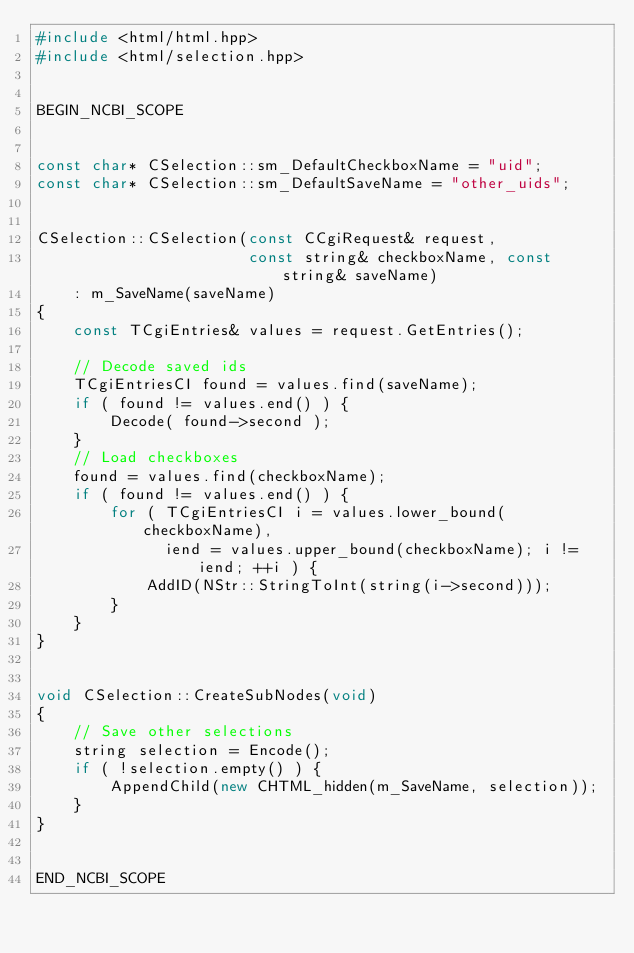<code> <loc_0><loc_0><loc_500><loc_500><_C++_>#include <html/html.hpp>
#include <html/selection.hpp>


BEGIN_NCBI_SCOPE


const char* CSelection::sm_DefaultCheckboxName = "uid";
const char* CSelection::sm_DefaultSaveName = "other_uids";


CSelection::CSelection(const CCgiRequest& request, 
                       const string& checkboxName, const string& saveName)
    : m_SaveName(saveName)
{
    const TCgiEntries& values = request.GetEntries();

    // Decode saved ids
    TCgiEntriesCI found = values.find(saveName);
    if ( found != values.end() ) {
        Decode( found->second );
    }
    // Load checkboxes
    found = values.find(checkboxName);
    if ( found != values.end() ) {
        for ( TCgiEntriesCI i = values.lower_bound(checkboxName),
              iend = values.upper_bound(checkboxName); i != iend; ++i ) {
            AddID(NStr::StringToInt(string(i->second)));
        }
    }
}


void CSelection::CreateSubNodes(void)
{
    // Save other selections
    string selection = Encode();
    if ( !selection.empty() ) {
        AppendChild(new CHTML_hidden(m_SaveName, selection));
    }
}


END_NCBI_SCOPE
</code> 